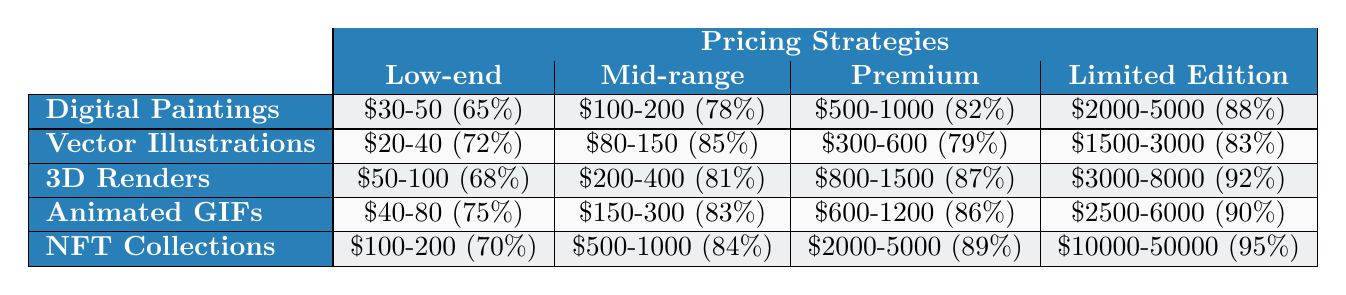What is the effectiveness of the Premium Pricing strategy for Digital Paintings? The table shows that the effectiveness of the Premium Pricing strategy for Digital Paintings is 82%.
Answer: 82% Which artwork style has the highest effectiveness with Limited Edition pricing? The effectiveness for Limited Edition pricing is 95% for NFT Collections, which is the highest among all styles.
Answer: 95% What is the price range for Mid-range Pricing of 3D Renders? The table indicates that the Mid-range Pricing for 3D Renders is between $200 and $400.
Answer: $200-400 Is the effectiveness of Vector Illustrations better with Mid-range or Limited Edition pricing? For Vector Illustrations, the effectiveness is 85% with Mid-range pricing and 83% with Limited Edition pricing. Since 85% is higher than 83%, it is better with Mid-range pricing.
Answer: Mid-range What is the average effectiveness of Low-end Pricing across all artwork styles? The effectiveness for Low-end Pricing is: Digital Paintings (65%), Vector Illustrations (72%), 3D Renders (68%), Animated GIFs (75%), and NFT Collections (70%). Summing these gives (65 + 72 + 68 + 75 + 70) = 350. There are 5 styles, so the average is 350/5 = 70.
Answer: 70 For 3D Renders, how much more effective is the Premium Pricing compared to the Low-end Pricing? The effectiveness for Premium Pricing of 3D Renders is 87% and for Low-end Pricing is 68%. The difference is 87 - 68 = 19%.
Answer: 19% Which artwork style shows a consistent increase in effectiveness from Low-end to Limited Edition pricing? Analyzing the effectiveness values: Digital Paintings (65% to 88%), Vector Illustrations (72% to 83%), 3D Renders (68% to 92%), Animated GIFs (75% to 90%), and NFT Collections (70% to 95%), shows all styles have higher effectiveness from Low-end to Limited Edition, indicating a consistent increase.
Answer: Yes What is the total effectiveness percentage for all pricing strategies combined for Animated GIFs? The effectiveness percentages for Animated GIFs are 75%, 83%, 86%, and 90%. Adding these gives 75 + 83 + 86 + 90 = 334.
Answer: 334 How does the effectiveness of NFT Collections compare with that of Digital Paintings in the Mid-range pricing strategy? The effectiveness of NFT Collections in the Mid-range pricing is 84% while for Digital Paintings it is 78%. Comparing 84% to 78%, NFT Collections are more effective.
Answer: More effective Is the effectiveness of the Low-end Pricing for Vector Illustrations greater than 70%? The effectiveness for Vector Illustrations’ Low-end Pricing is 72%, which is greater than 70%.
Answer: Yes 